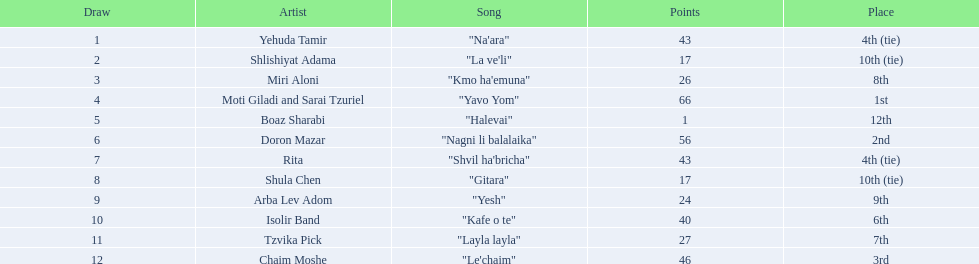What song is listed in the table right before layla layla? "Kafe o te". 